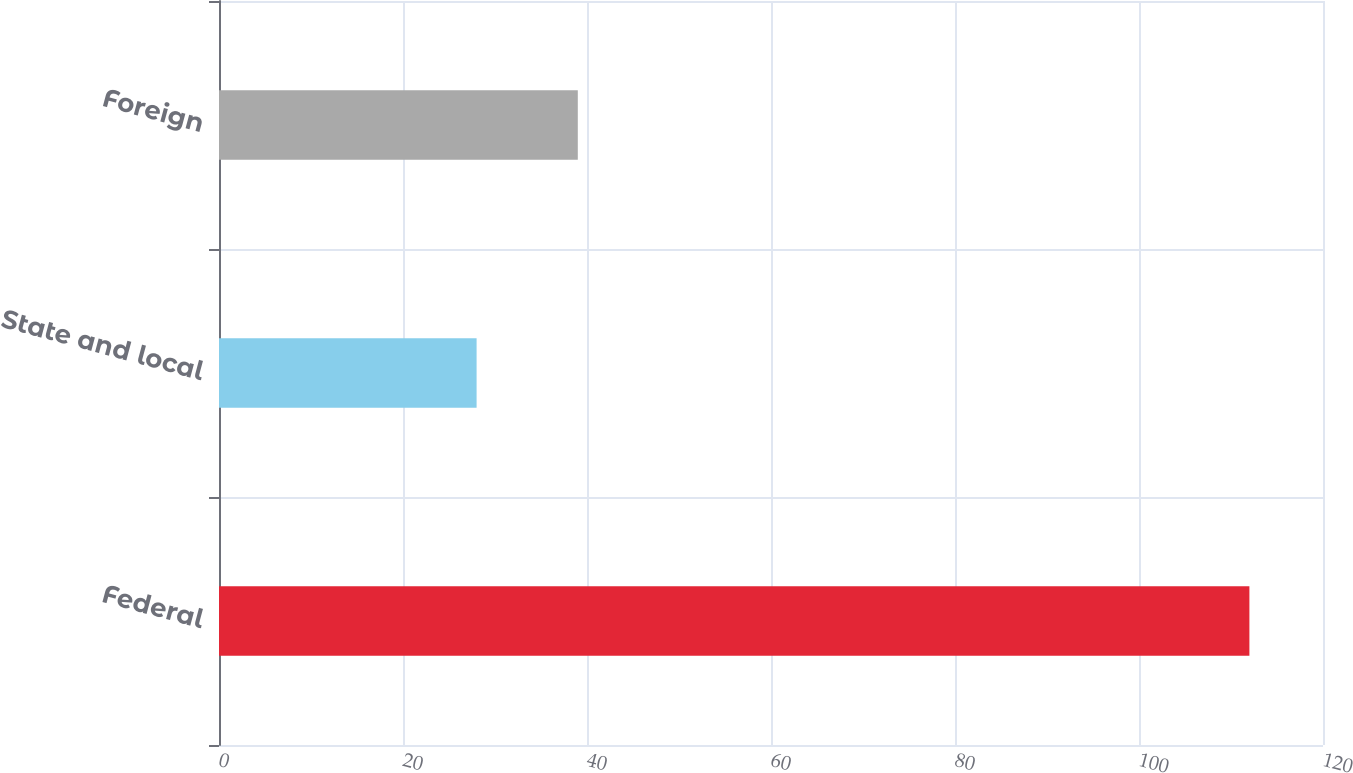Convert chart to OTSL. <chart><loc_0><loc_0><loc_500><loc_500><bar_chart><fcel>Federal<fcel>State and local<fcel>Foreign<nl><fcel>112<fcel>28<fcel>39<nl></chart> 